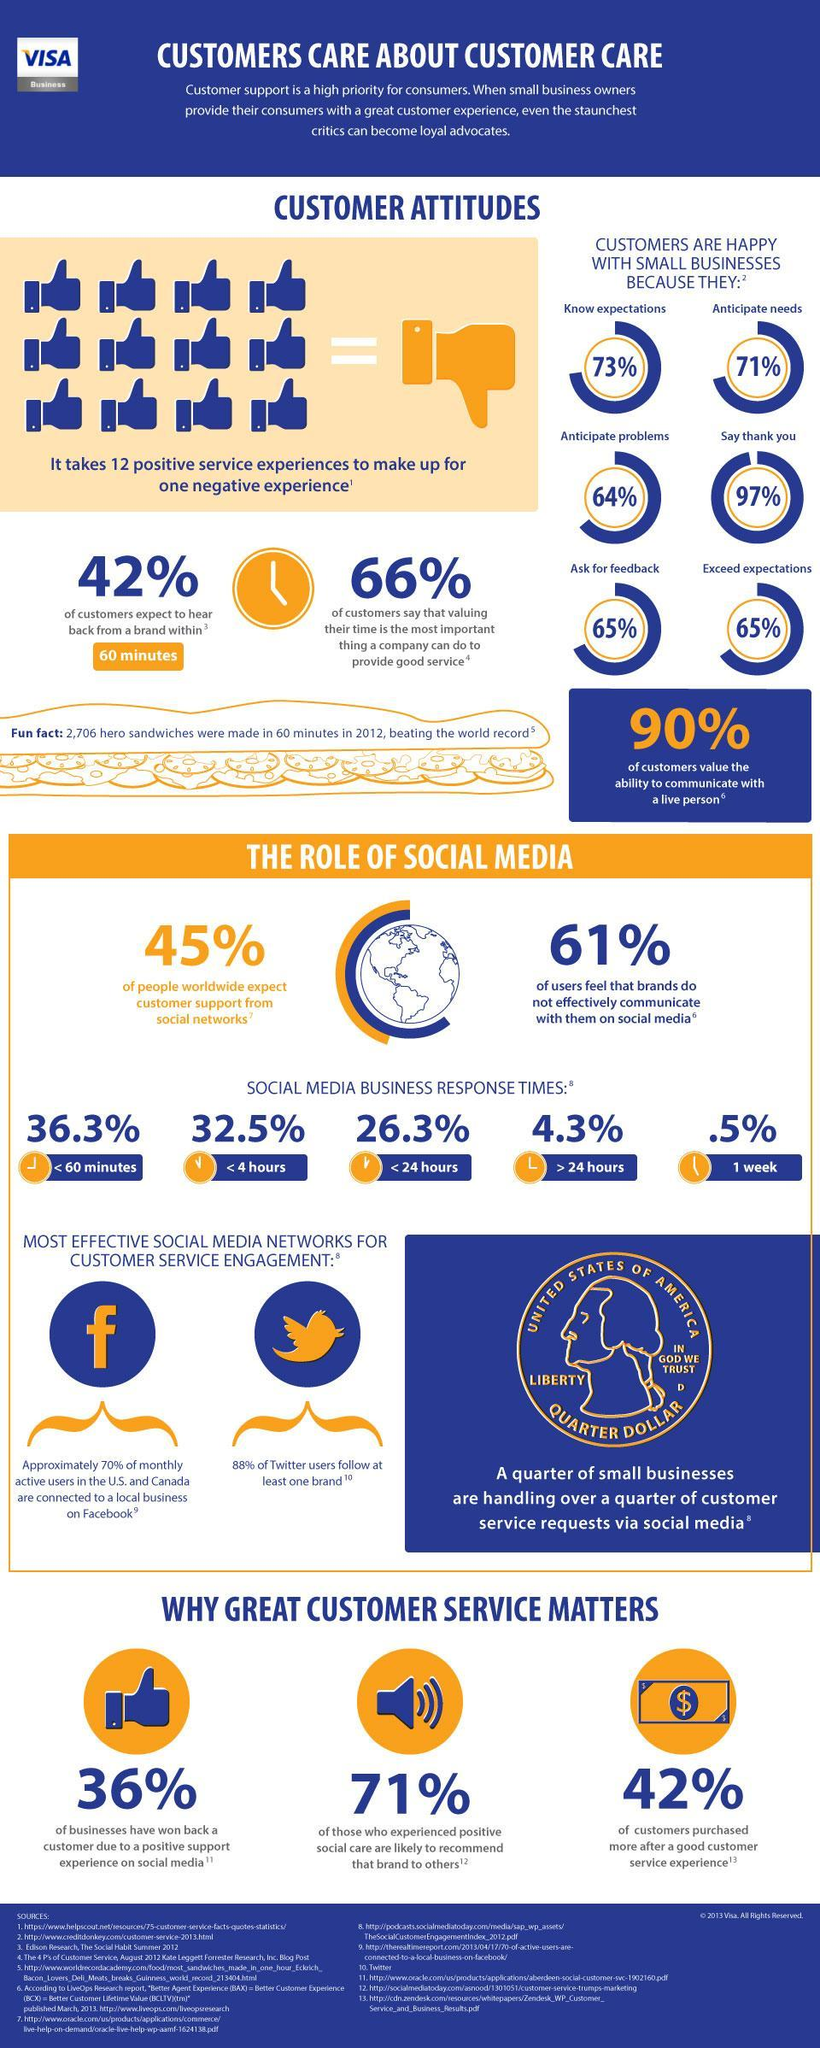Which denomination coin is shown in the infographic?
Answer the question with a short phrase. QUARTER DOLLAR What percent of customers do not expect to hear back from a brand within 60 minutes? 58% What percent of social media business respond within 7 days? .5% How many thumbs up symbols are shown in the infographic? 13 What percent of people feel that brands effectively communicate with them on social media? 39% 